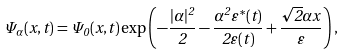<formula> <loc_0><loc_0><loc_500><loc_500>\Psi _ { \alpha } ( x , t ) = \Psi _ { 0 } ( x , t ) \exp \left ( - \frac { | \alpha | ^ { 2 } } { 2 } - \frac { \alpha ^ { 2 } \varepsilon ^ { * } ( t ) } { 2 \varepsilon ( t ) } + \frac { { \sqrt { 2 } } \alpha x } { \varepsilon } \right ) ,</formula> 